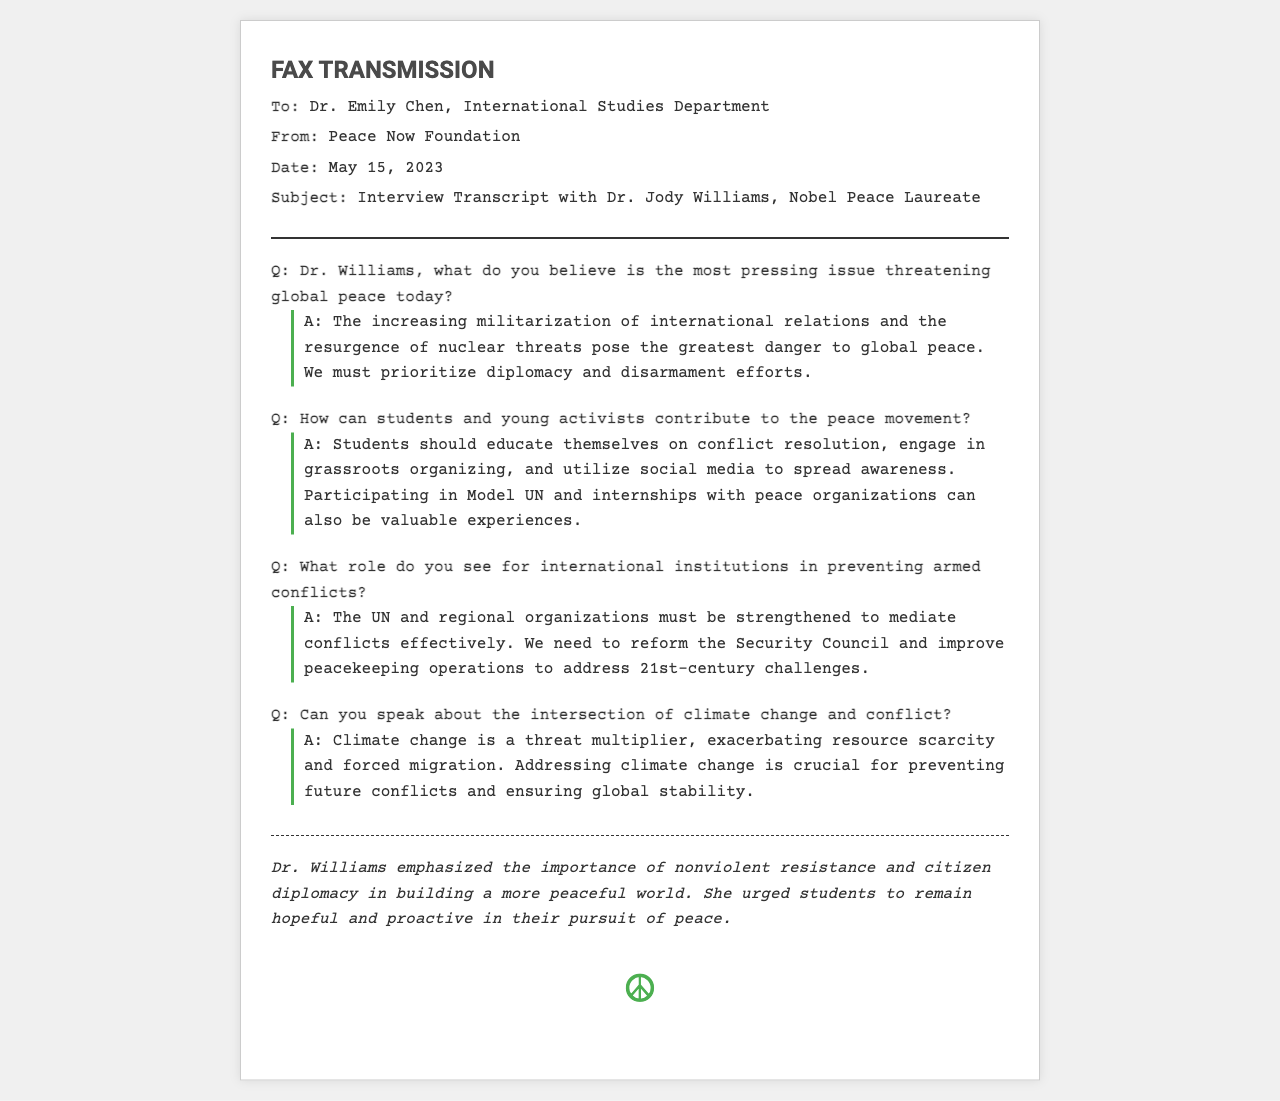what is the name of the peace activist interviewed? The document includes the name of the peace activist as "Dr. Jody Williams."
Answer: Dr. Jody Williams what is the date of the fax transmission? The date stated in the fax is "May 15, 2023."
Answer: May 15, 2023 who is the recipient of the fax? The recipient's name is specified as "Dr. Emily Chen."
Answer: Dr. Emily Chen what is the main pressing issue threatening global peace according to Dr. Williams? According to Dr. Williams, the pressing issue is "the increasing militarization of international relations and the resurgence of nuclear threats."
Answer: increasing militarization of international relations and the resurgence of nuclear threats what does Dr. Williams suggest students should do to contribute to the peace movement? Dr. Williams suggests that students should "educate themselves on conflict resolution, engage in grassroots organizing, and utilize social media to spread awareness."
Answer: educate themselves on conflict resolution, engage in grassroots organizing, and utilize social media how does Dr. Williams view the role of international institutions? She states that international institutions "must be strengthened to mediate conflicts effectively."
Answer: must be strengthened to mediate conflicts effectively what does Dr. Williams refer to as a "threat multiplier"? The document mentions "climate change" as a threat multiplier that exacerbates various issues.
Answer: climate change what is a crucial area Dr. Williams identifies for preventing future conflicts? Dr. Williams identifies "addressing climate change" as crucial for preventing future conflicts.
Answer: addressing climate change what does the fax discuss after the interview content? The fax includes a closing statement emphasizing Dr. Williams' views on "nonviolent resistance and citizen diplomacy."
Answer: nonviolent resistance and citizen diplomacy what symbol appears at the end of the document? The document concludes with the peace symbol "☮."
Answer: ☮ 